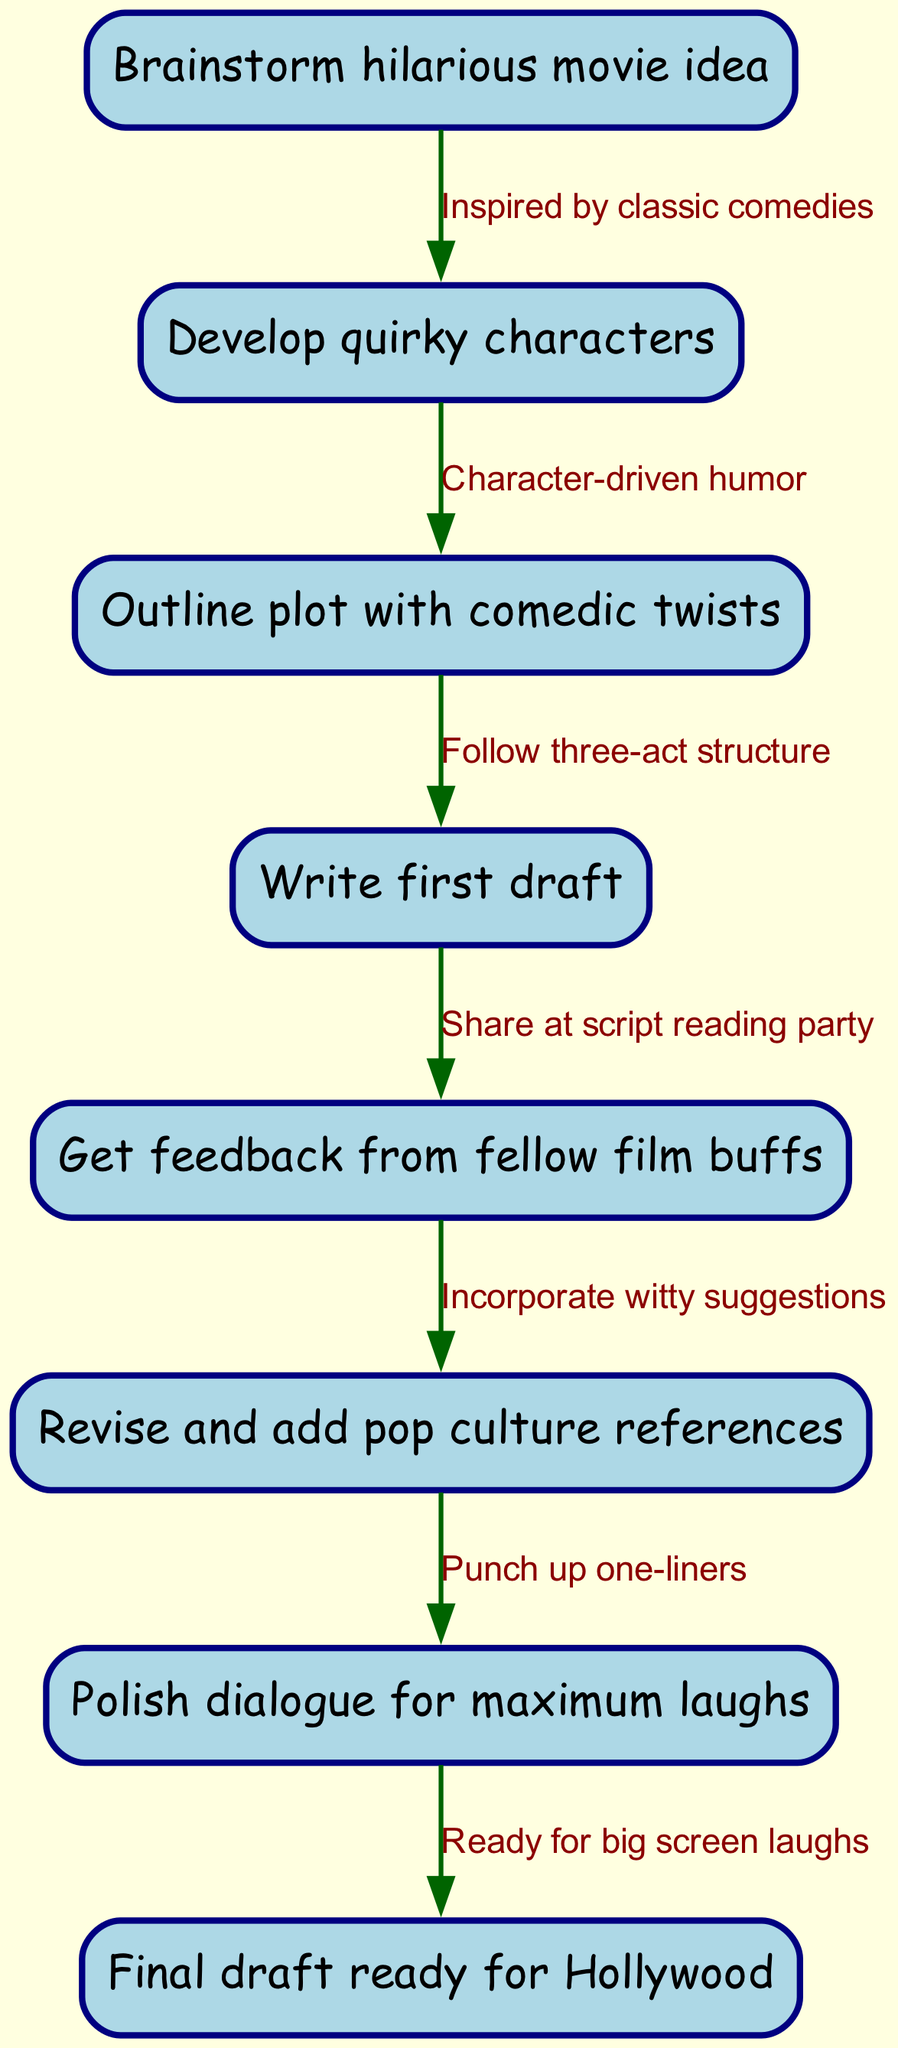What is the first step in the movie script writing process? According to the diagram, the first step is to brainstorm a hilarious movie idea, which is identified as Node 1.
Answer: Brainstorm hilarious movie idea How many nodes are in the diagram? By counting all the unique nodes listed in the diagram, we identify 8 nodes that represent different stages in the process.
Answer: 8 What is the relationship between "Write first draft" and "Get feedback from fellow film buffs"? The diagram indicates that "Write first draft" (Node 4) leads to "Get feedback from fellow film buffs" (Node 5) via a directed edge that describes the action as sharing at a script reading party.
Answer: Share at script reading party Which stage focuses on polishing dialogue? The diagram specifies that the stage dedicated to polishing dialogue is "Polish dialogue for maximum laughs," which corresponds to Node 7.
Answer: Polish dialogue for maximum laughs What step follows "Revise and add pop culture references"? Following Node 6, which is "Revise and add pop culture references," the next step is "Polish dialogue for maximum laughs" (Node 7). This can be inferred from the directed edge connecting the nodes.
Answer: Polish dialogue for maximum laughs Which node is focused on character development? The diagram shows that "Develop quirky characters" (Node 2) is the node that highlights character development in the film script writing process.
Answer: Develop quirky characters How does character-driven humor contribute to the script writing process? The diagram reveals that character-driven humor, represented by the edge connecting Node 2 ("Develop quirky characters") to Node 3 ("Outline plot with comedic twists"), emphasizes the importance of character in shaping the plot.
Answer: Character-driven humor What is necessary before arriving at the final draft? Before reaching the final draft, one must complete the "Polish dialogue for maximum laughs" step (Node 7), which is essential for ensuring that the script is ready for the big screen.
Answer: Polish dialogue for maximum laughs 